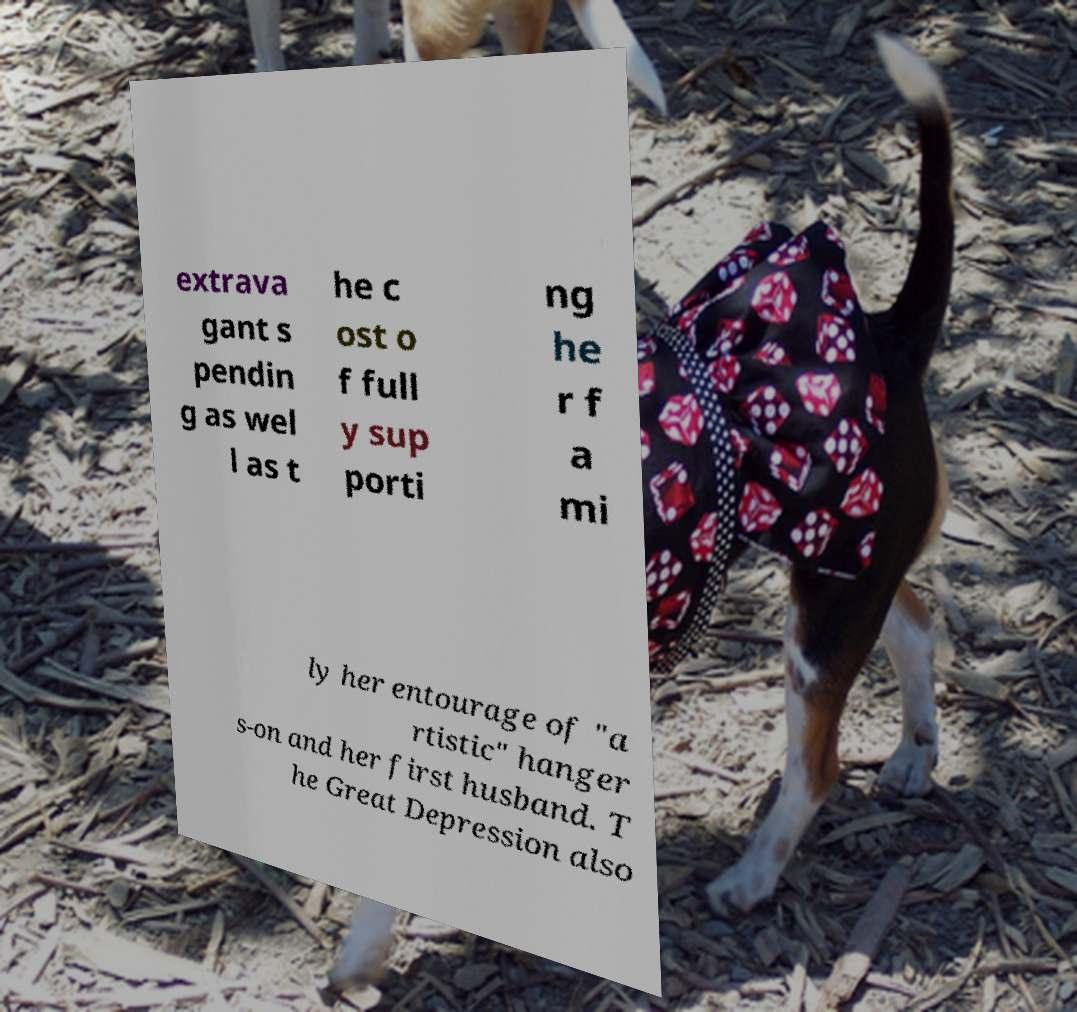Please read and relay the text visible in this image. What does it say? extrava gant s pendin g as wel l as t he c ost o f full y sup porti ng he r f a mi ly her entourage of "a rtistic" hanger s-on and her first husband. T he Great Depression also 